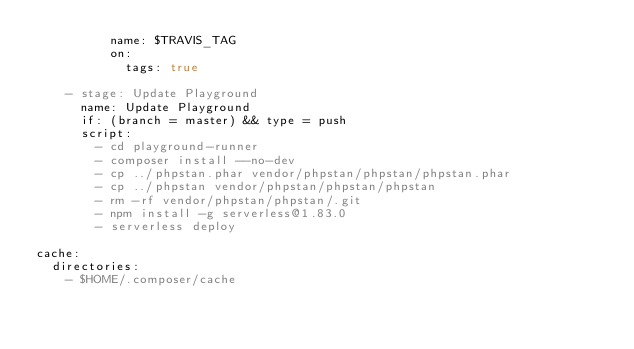<code> <loc_0><loc_0><loc_500><loc_500><_YAML_>          name: $TRAVIS_TAG
          on:
            tags: true

    - stage: Update Playground
      name: Update Playground
      if: (branch = master) && type = push
      script:
        - cd playground-runner
        - composer install --no-dev
        - cp ../phpstan.phar vendor/phpstan/phpstan/phpstan.phar
        - cp ../phpstan vendor/phpstan/phpstan/phpstan
        - rm -rf vendor/phpstan/phpstan/.git
        - npm install -g serverless@1.83.0
        - serverless deploy

cache:
  directories:
    - $HOME/.composer/cache
</code> 